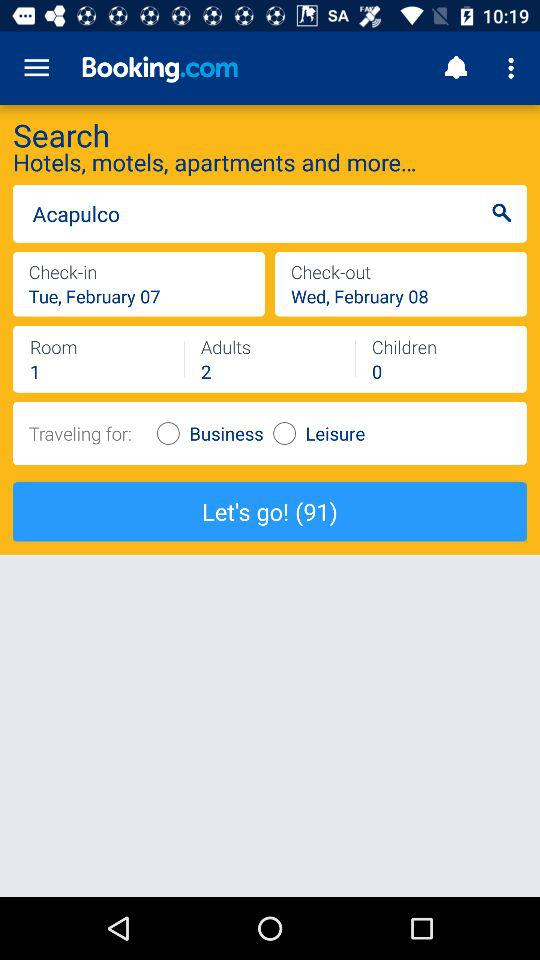How many adults are travelling?
Answer the question using a single word or phrase. 2 